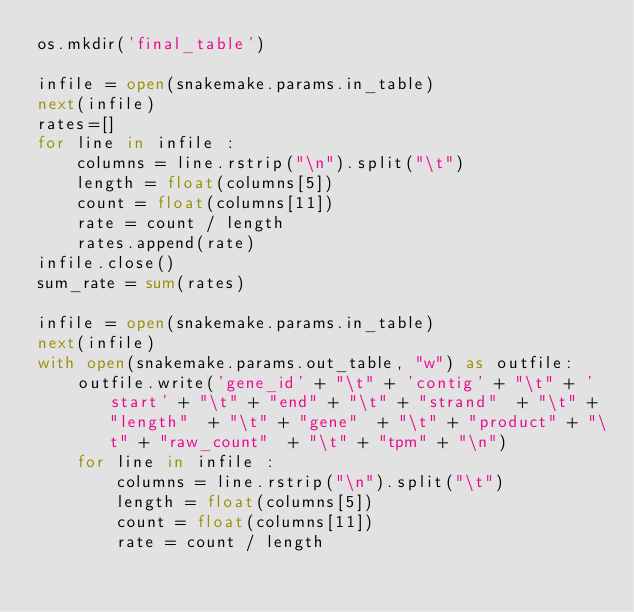Convert code to text. <code><loc_0><loc_0><loc_500><loc_500><_Python_>os.mkdir('final_table')

infile = open(snakemake.params.in_table)
next(infile)
rates=[]
for line in infile :
    columns = line.rstrip("\n").split("\t")
    length = float(columns[5])
    count = float(columns[11])
    rate = count / length
    rates.append(rate)
infile.close()   
sum_rate = sum(rates)

infile = open(snakemake.params.in_table)
next(infile)
with open(snakemake.params.out_table, "w") as outfile:
    outfile.write('gene_id' + "\t" + 'contig' + "\t" + 'start' + "\t" + "end" + "\t" + "strand"  + "\t" + "length"  + "\t" + "gene"  + "\t" + "product" + "\t" + "raw_count"  + "\t" + "tpm" + "\n")
    for line in infile :
        columns = line.rstrip("\n").split("\t")
        length = float(columns[5])
        count = float(columns[11])
        rate = count / length</code> 